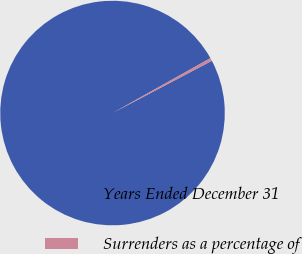Convert chart. <chart><loc_0><loc_0><loc_500><loc_500><pie_chart><fcel>Years Ended December 31<fcel>Surrenders as a percentage of<nl><fcel>99.57%<fcel>0.43%<nl></chart> 